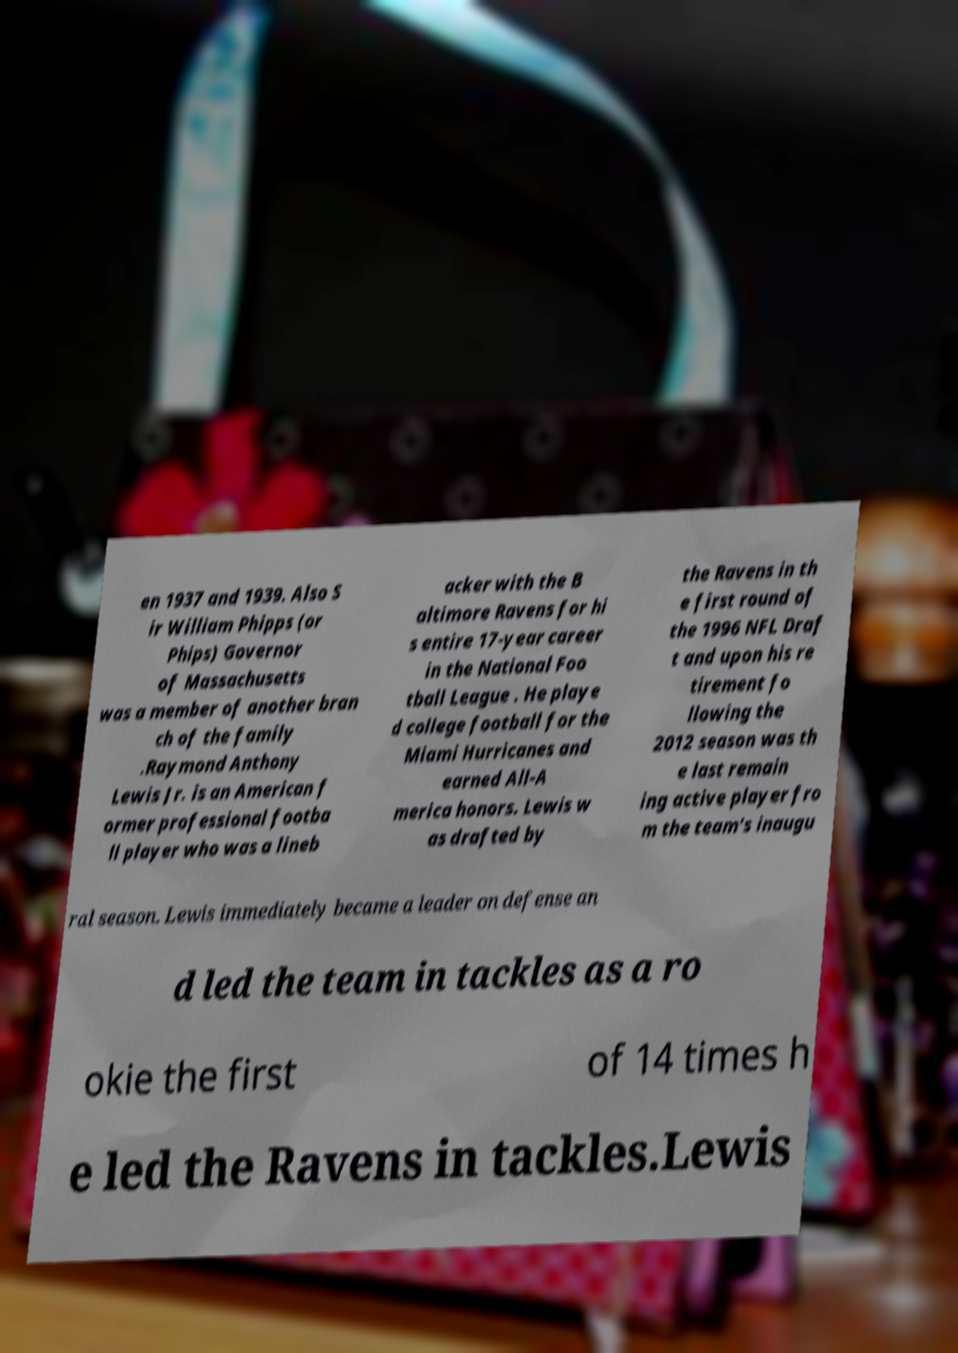For documentation purposes, I need the text within this image transcribed. Could you provide that? en 1937 and 1939. Also S ir William Phipps (or Phips) Governor of Massachusetts was a member of another bran ch of the family .Raymond Anthony Lewis Jr. is an American f ormer professional footba ll player who was a lineb acker with the B altimore Ravens for hi s entire 17-year career in the National Foo tball League . He playe d college football for the Miami Hurricanes and earned All-A merica honors. Lewis w as drafted by the Ravens in th e first round of the 1996 NFL Draf t and upon his re tirement fo llowing the 2012 season was th e last remain ing active player fro m the team's inaugu ral season. Lewis immediately became a leader on defense an d led the team in tackles as a ro okie the first of 14 times h e led the Ravens in tackles.Lewis 